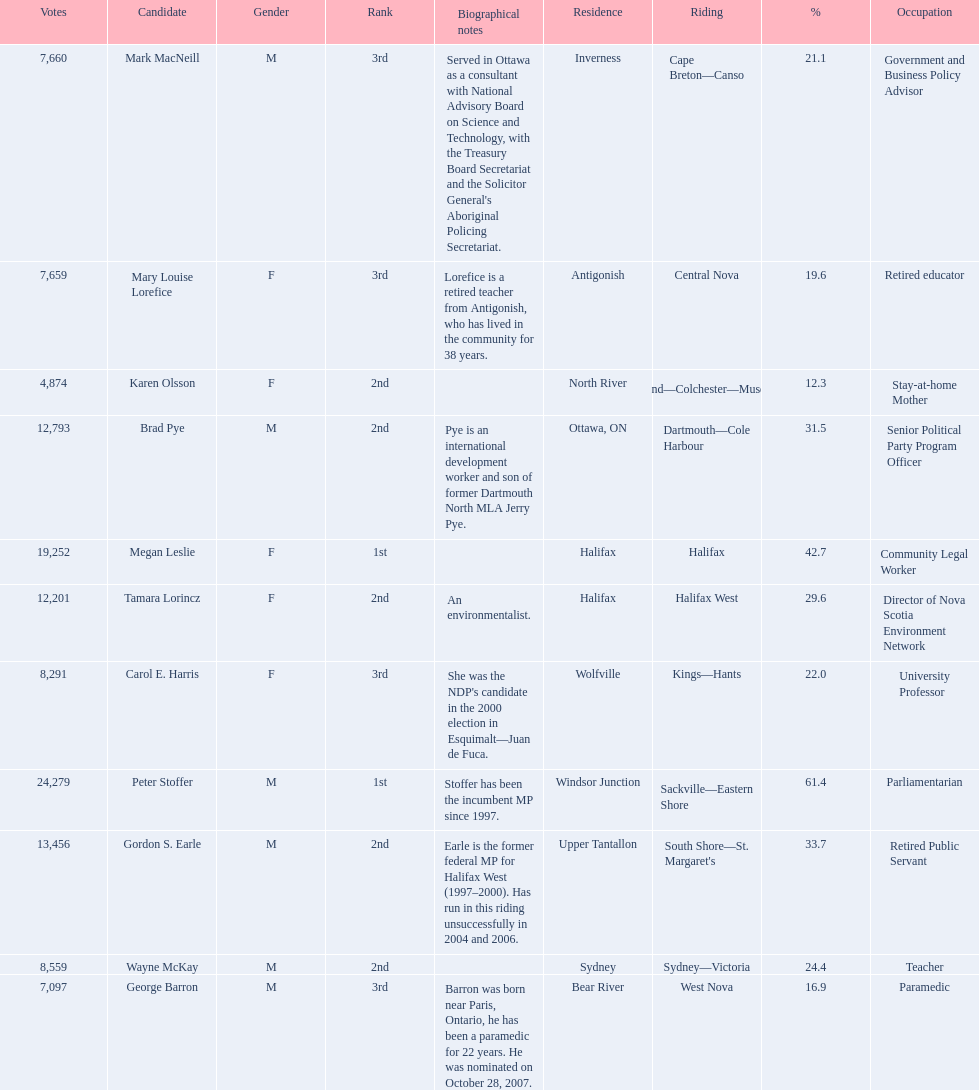What is the number of votes that megan leslie received? 19,252. 